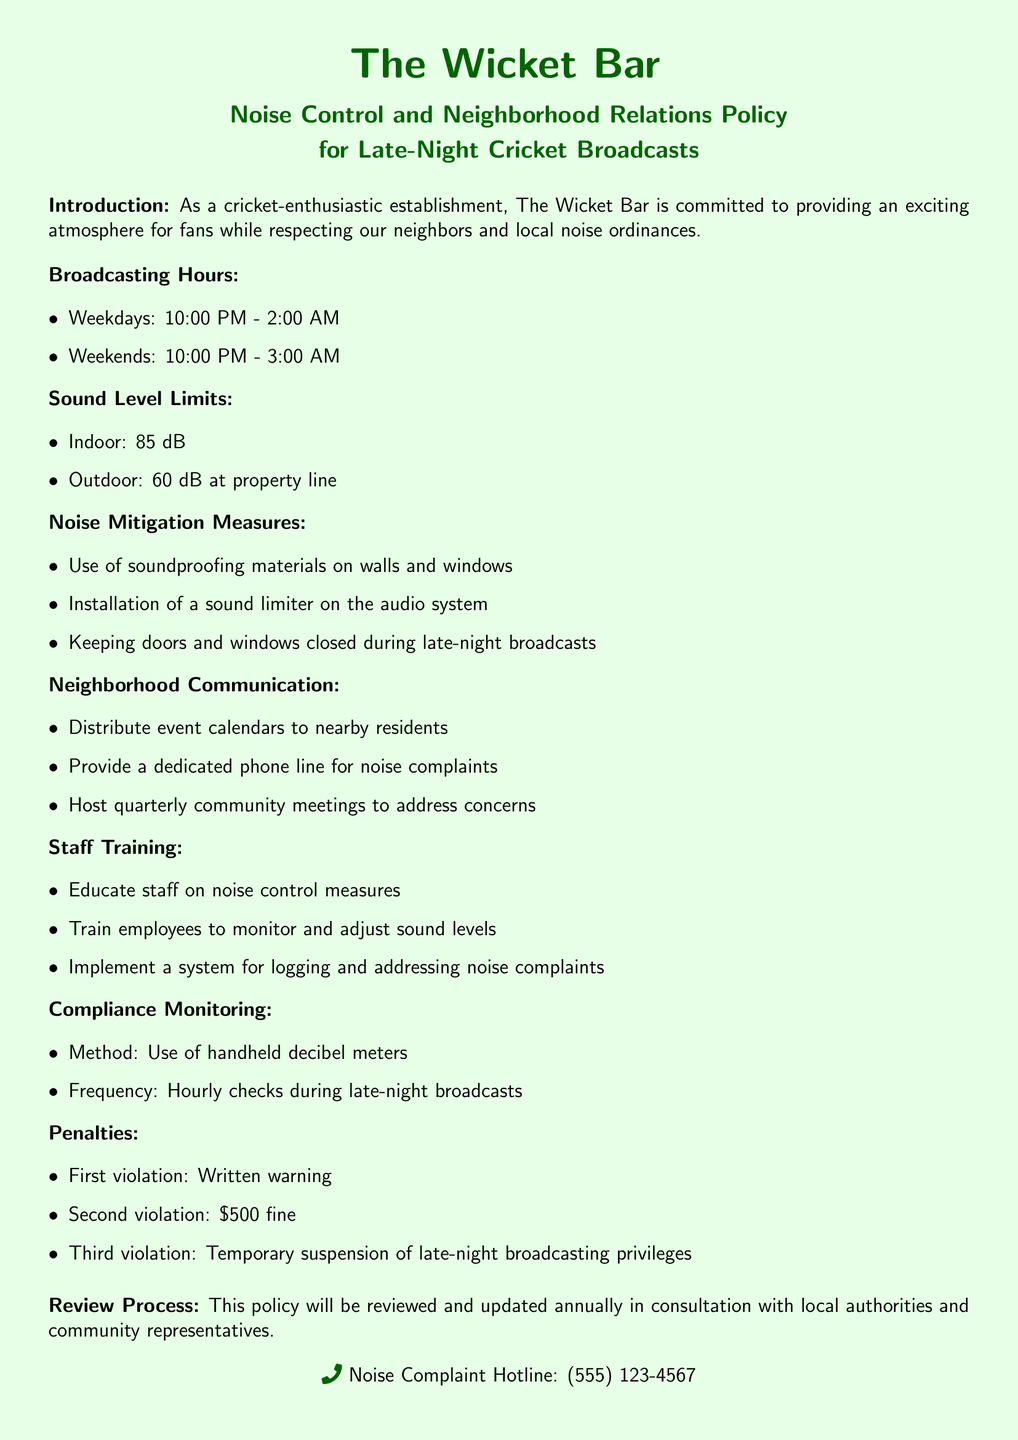What are the broadcasting hours on weekdays? The broadcasting hours on weekdays are specified in the document under the "Broadcasting Hours" section.
Answer: 10:00 PM - 2:00 AM What is the indoor sound level limit? The indoor sound level limit is stated in the "Sound Level Limits" section.
Answer: 85 dB What measures are included in noise mitigation? The noise mitigation measures are listed in the "Noise Mitigation Measures" section, detailing how noise will be controlled.
Answer: Soundproofing materials, sound limiter, closed doors/windows How often will compliance monitoring be conducted? The frequency of compliance monitoring is detailed in the "Compliance Monitoring" section.
Answer: Hourly checks What is the penalty for the third noise violation? The penalty for the third violation is outlined under the "Penalties" section.
Answer: Temporary suspension of late-night broadcasting privileges How will staff be trained regarding noise control? The training provided to staff is detailed in the "Staff Training" section, which describes procedures for noise control education.
Answer: On noise control measures What will be done with noise complaints? The handling of noise complaints is part of the operational procedures defined in the document.
Answer: Logging and addressing noise complaints When is the policy scheduled for review? The review process for the policy is described in the last paragraph, indicating the frequency of updates.
Answer: Annually What noise complaint hotline number is provided? The noise complaint hotline is clearly stated at the bottom of the document.
Answer: (555) 123-4567 